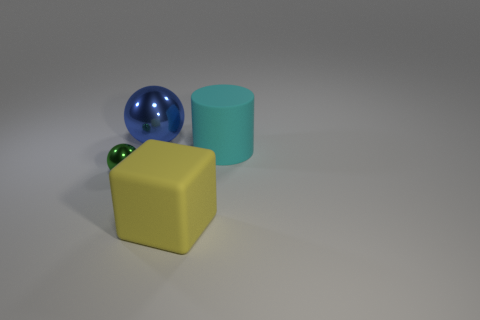What textures do the objects have? The objects appear to have a smooth texture. There are no distinct markings or roughness that can be seen on the surfaces of the cylinder, cube, or sphere.  Do the objects look like they belong to a specific setting or environment? Not particularly. The objects are presented on a neutral grey background and the setting does not evoke a specific environment. It looks like they are arranged for display or as part of a simple composition, perhaps for a study of forms and colors. 